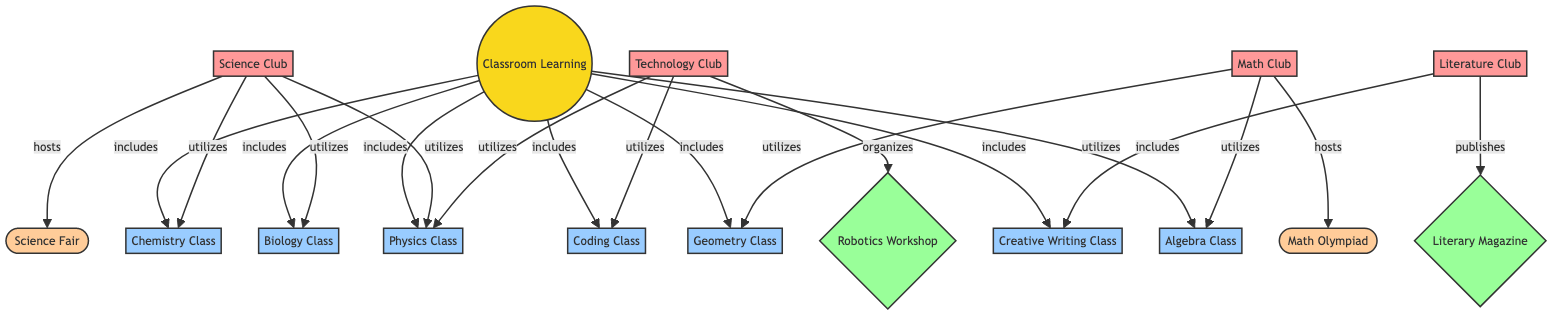What is the main node in the diagram? The main node in the diagram is labeled "Classroom Learning", which is the central node connecting to all other nodes.
Answer: Classroom Learning How many club activities are listed in the diagram? The diagram lists four clubs: Science Club, Math Club, Literature Club, and Technology Club. The count of these nodes is four.
Answer: 4 Which class does the Technology Club utilize? The Technology Club utilizes both the Coding Class and the Physics Class as shown by the links connected to these subject nodes.
Answer: Coding Class, Physics Class Which event does the Science Club host? The Science Club hosts an event called "Science Fair", which is indicated by the connection linking the Science Club to the Science Fair event node.
Answer: Science Fair What subject does the Literature Club utilize? The Literature Club utilizes the Creative Writing Class, as indicated by the direct connection between the Literature Club and this subject node in the diagram.
Answer: Creative Writing Class Which club is connected to the Math Olympiad? The Math Club is connected to the Math Olympiad, which is evident from the link showing that the Math Club hosts this specific event.
Answer: Math Club Which subject is utilized by both the Science Club and Technology Club? The subject "Physics Class" is utilized by both the Science Club and Technology Club as indicated by the connections from both clubs to the Physics Class node.
Answer: Physics Class Which club publishes a literary magazine? The Literature Club publishes a literary magazine, as shown by the link that connects the Literature Club to the Literary Magazine activity node.
Answer: Literature Club What type of diagram is being represented here? This is a Network Diagram illustrating the connections between classroom learning topics, club activities, and events. The structure shows how various elements are interrelated.
Answer: Network Diagram 